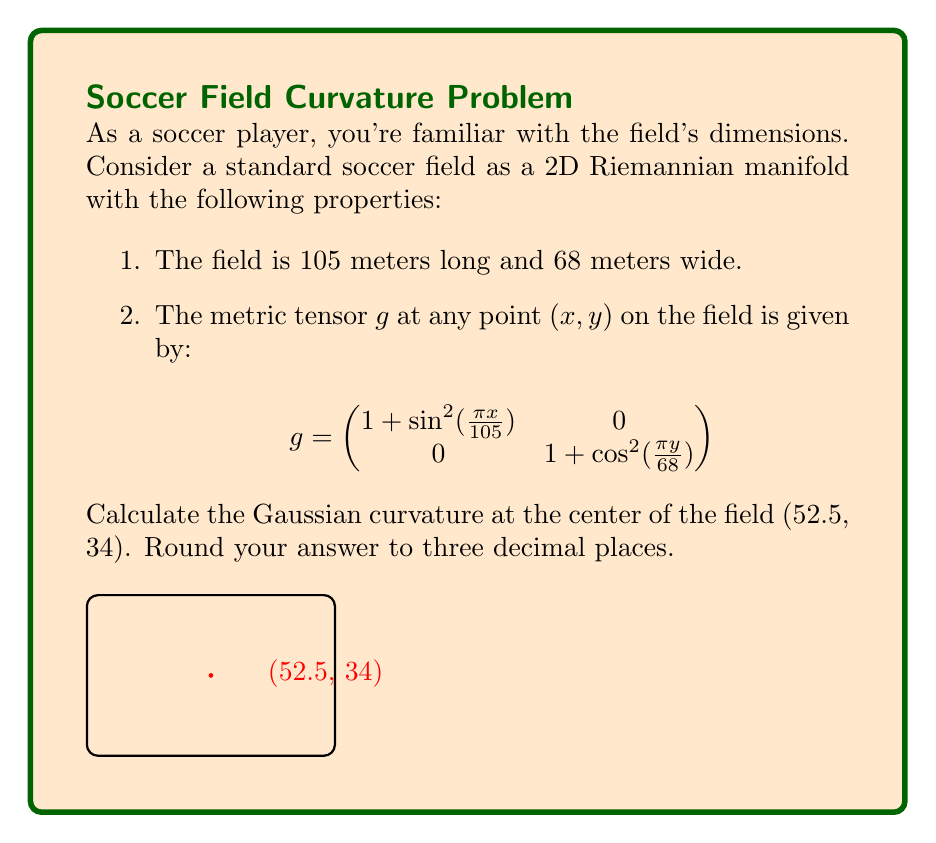What is the answer to this math problem? To calculate the Gaussian curvature of a 2D Riemannian manifold, we need to use the following formula:

$$K = -\frac{1}{2\sqrt{|g|}}\left(\frac{\partial}{\partial x}\left(\frac{\sqrt{|g|}}{g_{11}}\frac{\partial g_{11}}{\partial x}\right) + \frac{\partial}{\partial y}\left(\frac{\sqrt{|g|}}{g_{22}}\frac{\partial g_{22}}{\partial y}\right)\right)$$

Where $|g|$ is the determinant of the metric tensor.

Step 1: Calculate the components of the metric tensor at (52.5, 34):
$g_{11} = 1 + \sin^2(\frac{\pi \cdot 52.5}{105}) = 1 + \sin^2(\frac{\pi}{2}) = 2$
$g_{22} = 1 + \cos^2(\frac{\pi \cdot 34}{68}) = 1 + \cos^2(\frac{\pi}{2}) = 1$

Step 2: Calculate the determinant of $g$:
$|g| = g_{11} \cdot g_{22} = 2 \cdot 1 = 2$

Step 3: Calculate the partial derivatives:
$\frac{\partial g_{11}}{\partial x} = \frac{2\pi}{105}\sin(\frac{\pi x}{105})\cos(\frac{\pi x}{105})$
$\frac{\partial g_{22}}{\partial y} = -\frac{2\pi}{68}\sin(\frac{\pi y}{68})\cos(\frac{\pi y}{68})$

Step 4: Evaluate the partial derivatives at (52.5, 34):
$\frac{\partial g_{11}}{\partial x}|_{(52.5,34)} = 0$
$\frac{\partial g_{22}}{\partial y}|_{(52.5,34)} = 0$

Step 5: Calculate the second partial derivatives:
$\frac{\partial}{\partial x}\left(\frac{\sqrt{|g|}}{g_{11}}\frac{\partial g_{11}}{\partial x}\right) = \frac{\partial}{\partial x}\left(\frac{\sqrt{2}}{2} \cdot 0\right) = 0$
$\frac{\partial}{\partial y}\left(\frac{\sqrt{|g|}}{g_{22}}\frac{\partial g_{22}}{\partial y}\right) = \frac{\partial}{\partial y}\left(\sqrt{2} \cdot 0\right) = 0$

Step 6: Apply the Gaussian curvature formula:
$$K = -\frac{1}{2\sqrt{2}}(0 + 0) = 0$$

Therefore, the Gaussian curvature at the center of the field (52.5, 34) is 0.
Answer: $0$ 